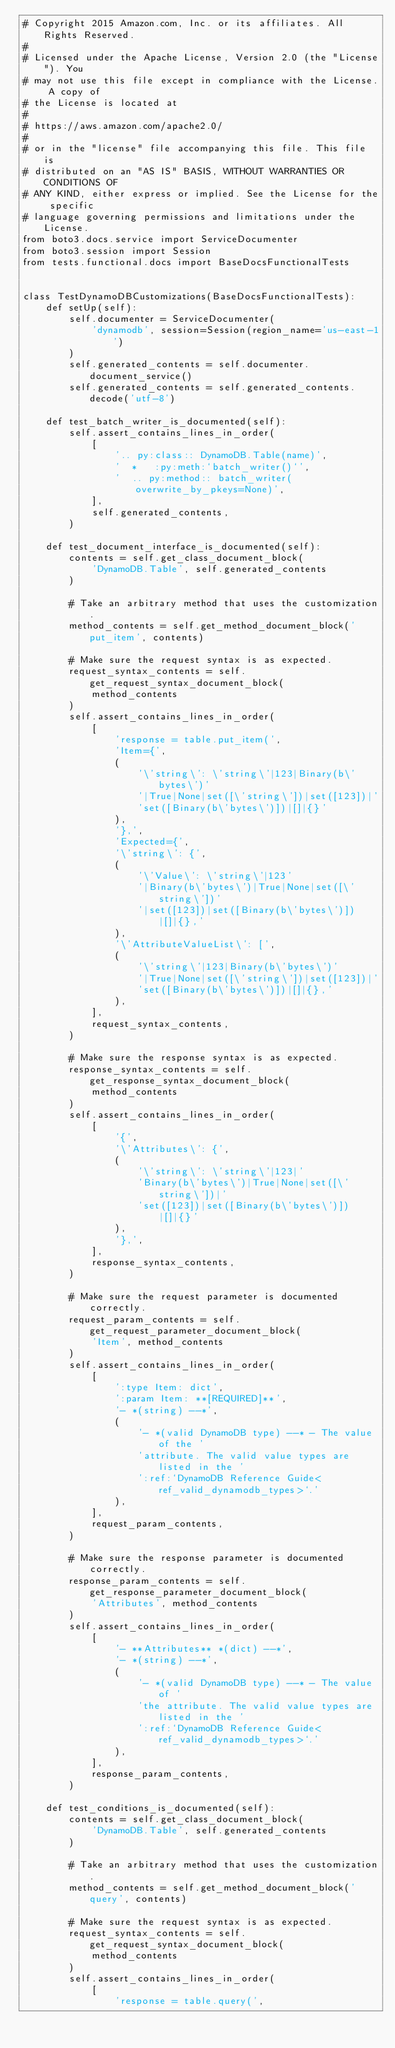<code> <loc_0><loc_0><loc_500><loc_500><_Python_># Copyright 2015 Amazon.com, Inc. or its affiliates. All Rights Reserved.
#
# Licensed under the Apache License, Version 2.0 (the "License"). You
# may not use this file except in compliance with the License. A copy of
# the License is located at
#
# https://aws.amazon.com/apache2.0/
#
# or in the "license" file accompanying this file. This file is
# distributed on an "AS IS" BASIS, WITHOUT WARRANTIES OR CONDITIONS OF
# ANY KIND, either express or implied. See the License for the specific
# language governing permissions and limitations under the License.
from boto3.docs.service import ServiceDocumenter
from boto3.session import Session
from tests.functional.docs import BaseDocsFunctionalTests


class TestDynamoDBCustomizations(BaseDocsFunctionalTests):
    def setUp(self):
        self.documenter = ServiceDocumenter(
            'dynamodb', session=Session(region_name='us-east-1')
        )
        self.generated_contents = self.documenter.document_service()
        self.generated_contents = self.generated_contents.decode('utf-8')

    def test_batch_writer_is_documented(self):
        self.assert_contains_lines_in_order(
            [
                '.. py:class:: DynamoDB.Table(name)',
                '  *   :py:meth:`batch_writer()`',
                '  .. py:method:: batch_writer(overwrite_by_pkeys=None)',
            ],
            self.generated_contents,
        )

    def test_document_interface_is_documented(self):
        contents = self.get_class_document_block(
            'DynamoDB.Table', self.generated_contents
        )

        # Take an arbitrary method that uses the customization.
        method_contents = self.get_method_document_block('put_item', contents)

        # Make sure the request syntax is as expected.
        request_syntax_contents = self.get_request_syntax_document_block(
            method_contents
        )
        self.assert_contains_lines_in_order(
            [
                'response = table.put_item(',
                'Item={',
                (
                    '\'string\': \'string\'|123|Binary(b\'bytes\')'
                    '|True|None|set([\'string\'])|set([123])|'
                    'set([Binary(b\'bytes\')])|[]|{}'
                ),
                '},',
                'Expected={',
                '\'string\': {',
                (
                    '\'Value\': \'string\'|123'
                    '|Binary(b\'bytes\')|True|None|set([\'string\'])'
                    '|set([123])|set([Binary(b\'bytes\')])|[]|{},'
                ),
                '\'AttributeValueList\': [',
                (
                    '\'string\'|123|Binary(b\'bytes\')'
                    '|True|None|set([\'string\'])|set([123])|'
                    'set([Binary(b\'bytes\')])|[]|{},'
                ),
            ],
            request_syntax_contents,
        )

        # Make sure the response syntax is as expected.
        response_syntax_contents = self.get_response_syntax_document_block(
            method_contents
        )
        self.assert_contains_lines_in_order(
            [
                '{',
                '\'Attributes\': {',
                (
                    '\'string\': \'string\'|123|'
                    'Binary(b\'bytes\')|True|None|set([\'string\'])|'
                    'set([123])|set([Binary(b\'bytes\')])|[]|{}'
                ),
                '},',
            ],
            response_syntax_contents,
        )

        # Make sure the request parameter is documented correctly.
        request_param_contents = self.get_request_parameter_document_block(
            'Item', method_contents
        )
        self.assert_contains_lines_in_order(
            [
                ':type Item: dict',
                ':param Item: **[REQUIRED]**',
                '- *(string) --*',
                (
                    '- *(valid DynamoDB type) --* - The value of the '
                    'attribute. The valid value types are listed in the '
                    ':ref:`DynamoDB Reference Guide<ref_valid_dynamodb_types>`.'
                ),
            ],
            request_param_contents,
        )

        # Make sure the response parameter is documented correctly.
        response_param_contents = self.get_response_parameter_document_block(
            'Attributes', method_contents
        )
        self.assert_contains_lines_in_order(
            [
                '- **Attributes** *(dict) --*',
                '- *(string) --*',
                (
                    '- *(valid DynamoDB type) --* - The value of '
                    'the attribute. The valid value types are listed in the '
                    ':ref:`DynamoDB Reference Guide<ref_valid_dynamodb_types>`.'
                ),
            ],
            response_param_contents,
        )

    def test_conditions_is_documented(self):
        contents = self.get_class_document_block(
            'DynamoDB.Table', self.generated_contents
        )

        # Take an arbitrary method that uses the customization.
        method_contents = self.get_method_document_block('query', contents)

        # Make sure the request syntax is as expected.
        request_syntax_contents = self.get_request_syntax_document_block(
            method_contents
        )
        self.assert_contains_lines_in_order(
            [
                'response = table.query(',</code> 